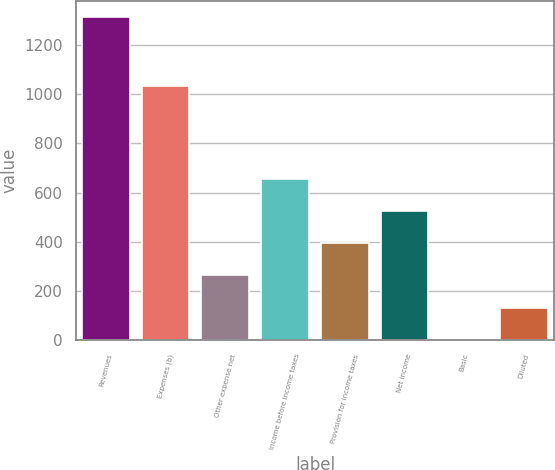Convert chart to OTSL. <chart><loc_0><loc_0><loc_500><loc_500><bar_chart><fcel>Revenues<fcel>Expenses (b)<fcel>Other expense net<fcel>Income before income taxes<fcel>Provision for income taxes<fcel>Net income<fcel>Basic<fcel>Diluted<nl><fcel>1314.1<fcel>1032.6<fcel>263.02<fcel>657.16<fcel>394.4<fcel>525.78<fcel>0.26<fcel>131.64<nl></chart> 